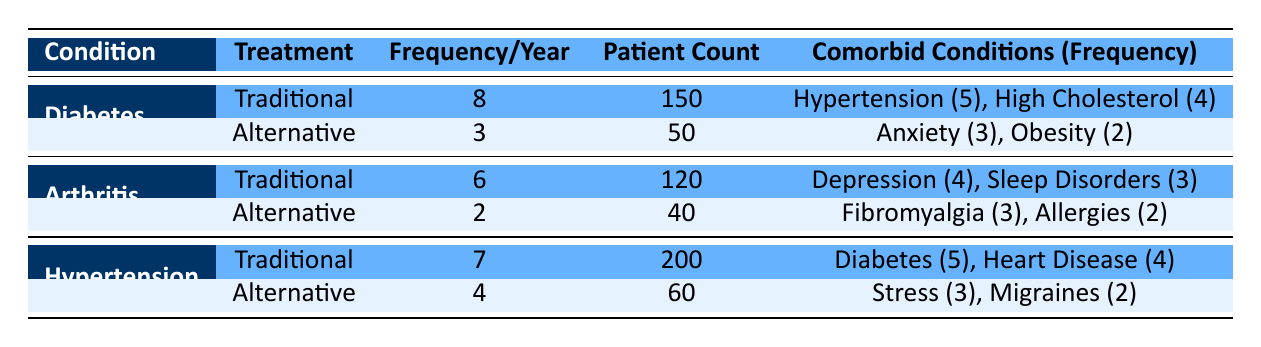What's the frequency of health consultations per year for patients with diabetes using traditional remedies? The table shows that for diabetes, the frequency of health consultations using traditional remedies is 8 per year.
Answer: 8 How many patients are using alternative remedies for arthritis? According to the table, the patient count for those using alternative remedies for arthritis is 40.
Answer: 40 Is it true that patients with hypertension using traditional remedies have a higher consultation frequency than those using alternative remedies? For hypertension, the frequency of consultations is 7 for traditional remedies and 4 for alternative remedies, so the statement is true.
Answer: Yes What is the total frequency of health consultations per year for patients with chronic conditions using traditional remedies? The total frequency for traditional remedies is calculated by adding the frequencies for diabetes (8), arthritis (6), and hypertension (7), which is 8 + 6 + 7 = 21.
Answer: 21 Which chronic condition has the highest patient count using traditional remedies? The highest patient count among traditional remedies is for hypertension, with a count of 200.
Answer: Hypertension What is the average frequency of health consultations for patients using alternative remedies across all chronic conditions? The frequencies for alternative remedies are 3 (diabetes), 2 (arthritis), and 4 (hypertension). The total is 3 + 2 + 4 = 9, and dividing this by the number of conditions (3) gives an average of 9/3 = 3.
Answer: 3 Do patients with arthritis using traditional remedies have more comorbid conditions listed than those using alternative remedies? Traditional remedies for arthritis report 2 comorbid conditions (depression, sleep disorders), while alternative remedies list 2 (fibromyalgia, allergies), indicating no difference in the number of comorbid conditions. Therefore, the statement is false.
Answer: No What is the difference in patient count between those using traditional remedies for diabetes and those using alternative remedies? The patient count using traditional remedies for diabetes is 150, while for alternative remedies, it is 50. The difference is 150 - 50 = 100.
Answer: 100 For which condition is the difference between the frequencies of traditional and alternative remedies the largest? For diabetes, the difference between traditional (8) and alternative (3) is 5. For arthritis, it is 4 (6 - 2), and for hypertension, it is 3 (7 - 4). Thus, diabetes has the largest difference of 5.
Answer: Diabetes 